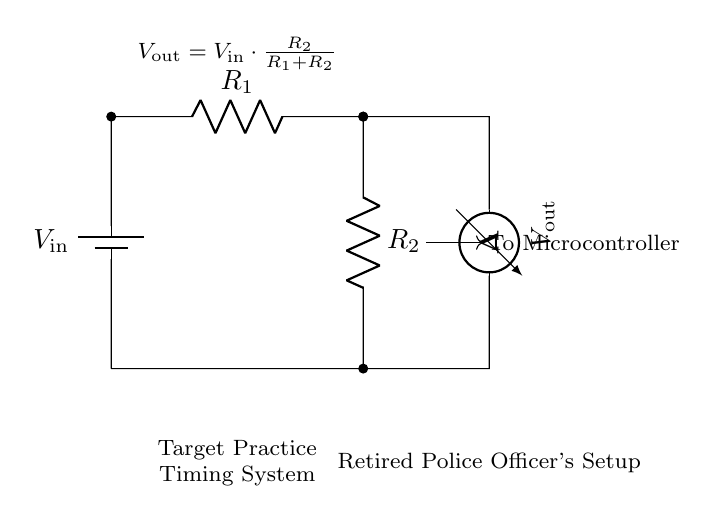What is the input voltage of the circuit? The input voltage, denoted as V_in, is represented by the battery symbol in the circuit diagram, indicating the power supply to the voltage divider.
Answer: V_in What are the resistance values present in the circuit? The circuit contains two resistors, R_1 and R_2, whose values are defined in the diagram. Since specific numerical values are not provided, we refer to them by name only.
Answer: R_1 and R_2 What is the formula for the output voltage in this circuit? The output voltage, V_out, is calculated using the voltage divider formula shown in the circuit: V_out = V_in multiplied by the ratio of R_2 to the total resistance (R_1 + R_2).
Answer: V_out = V_in * (R_2 / (R_1 + R_2)) How does changing R_1 affect V_out? Increasing R_1 while keeping R_2 constant will increase the total resistance (R_1 + R_2), which will decrease V_out due to the direct relationship between the resistances and output voltage, as expressed in the formula.
Answer: V_out decreases How does the microcontroller connect to this circuit? The circuit indicates a connection from the voltage output terminal, which is V_out, directly to the microcontroller. This signifies that the microcontroller reads the voltage for timing.
Answer: To microcontroller What role does R_2 play in the timing system? R_2 is part of the voltage divider that determines the output voltage, V_out, which is fed to the microcontroller for timing purposes, effectively controlling the timing signal based on its resistance value.
Answer: It determines V_out 